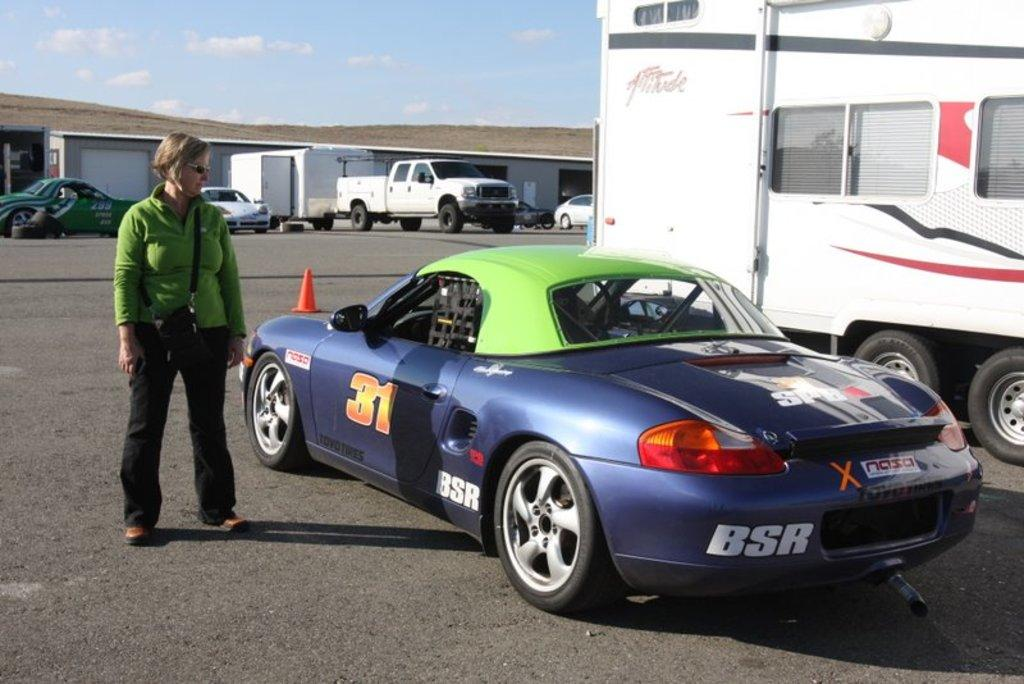What is located in the center of the image? There are vehicles and a person standing in the center of the image. Can you describe the vehicles in the image? There are vehicles in the center and background of the image. What is visible in the background of the image? There is a building and vehicles in the background of the image. How would you describe the weather in the image? The sky is cloudy in the image, suggesting a potentially overcast or rainy day. What type of ink can be seen spilling from the trees in the image? There are no trees or ink present in the image; it features vehicles and a person in the center, with a building and vehicles in the background. 